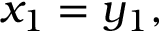<formula> <loc_0><loc_0><loc_500><loc_500>x _ { 1 } = y _ { 1 } ,</formula> 